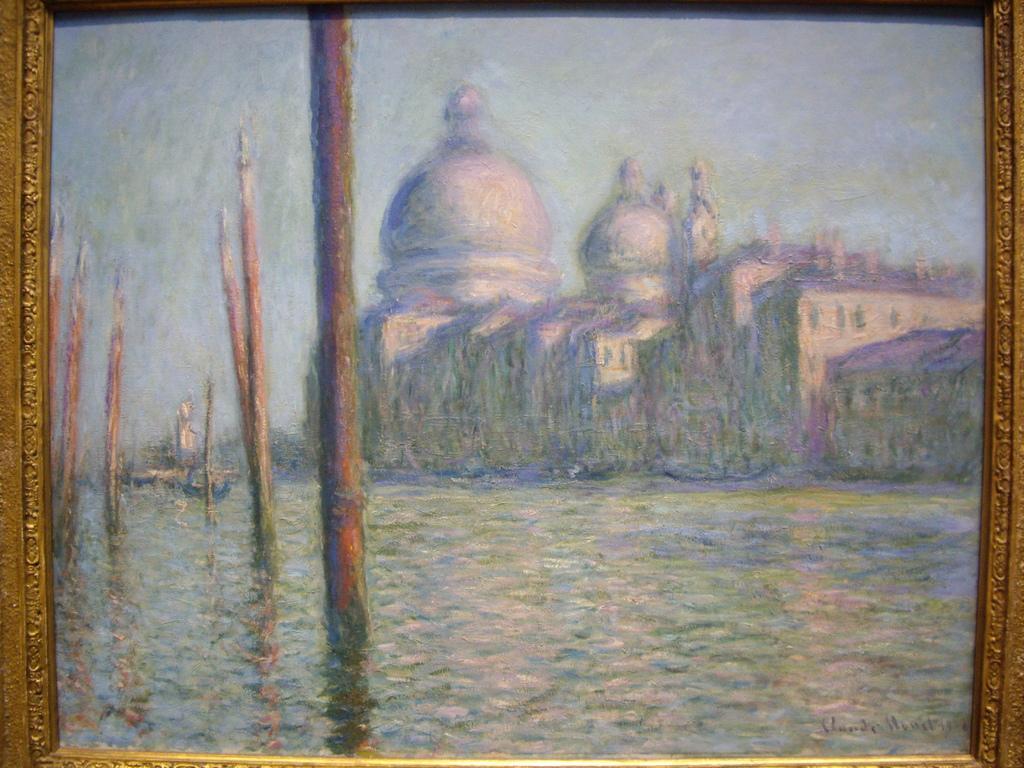Can you describe this image briefly? In the foreground of this picture we can see the painting of a water body and the painting of the buildings and the dome. In the background we can see the sky and the bamboos and we can see the wooden frame. 